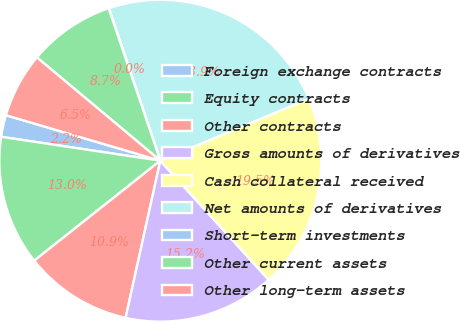<chart> <loc_0><loc_0><loc_500><loc_500><pie_chart><fcel>Foreign exchange contracts<fcel>Equity contracts<fcel>Other contracts<fcel>Gross amounts of derivatives<fcel>Cash collateral received<fcel>Net amounts of derivatives<fcel>Short-term investments<fcel>Other current assets<fcel>Other long-term assets<nl><fcel>2.19%<fcel>13.04%<fcel>10.87%<fcel>15.21%<fcel>19.55%<fcel>23.88%<fcel>0.03%<fcel>8.7%<fcel>6.53%<nl></chart> 